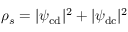Convert formula to latex. <formula><loc_0><loc_0><loc_500><loc_500>\rho _ { s } = | \psi _ { c d } | ^ { 2 } + | \psi _ { d c } | ^ { 2 }</formula> 